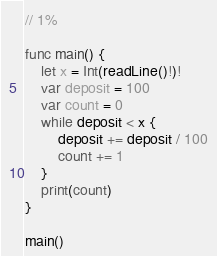<code> <loc_0><loc_0><loc_500><loc_500><_Swift_>// 1%

func main() {
    let x = Int(readLine()!)!
    var deposit = 100
    var count = 0
    while deposit < x {
        deposit += deposit / 100
        count += 1
    }
    print(count)
}

main()</code> 